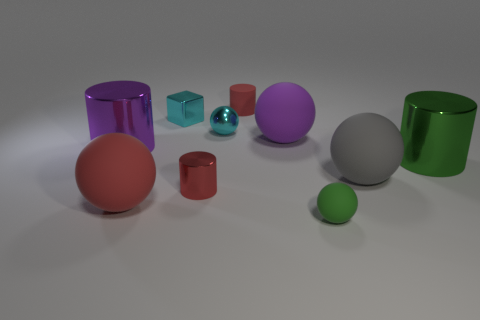Do the big gray object and the green matte thing have the same shape?
Ensure brevity in your answer.  Yes. There is a small green object that is the same shape as the large gray rubber thing; what is it made of?
Offer a terse response. Rubber. There is a rubber sphere that is behind the gray matte ball; how big is it?
Your response must be concise. Large. Are there the same number of large rubber things that are to the right of the green ball and large green shiny cylinders?
Your answer should be very brief. Yes. Is there a green object that has the same shape as the large red object?
Your answer should be compact. Yes. The small object that is both in front of the large purple matte object and left of the small red matte thing has what shape?
Keep it short and to the point. Cylinder. Is the large red object made of the same material as the tiny ball behind the tiny green matte thing?
Keep it short and to the point. No. There is a large gray thing; are there any rubber balls to the left of it?
Your response must be concise. Yes. What number of things are either large green cylinders or big rubber spheres that are in front of the big green cylinder?
Your response must be concise. 3. There is a large rubber ball that is behind the big shiny object on the left side of the big purple matte sphere; what is its color?
Offer a terse response. Purple. 